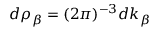<formula> <loc_0><loc_0><loc_500><loc_500>{ d \rho _ { \beta } = ( 2 \pi ) ^ { - 3 } d k _ { \beta } }</formula> 